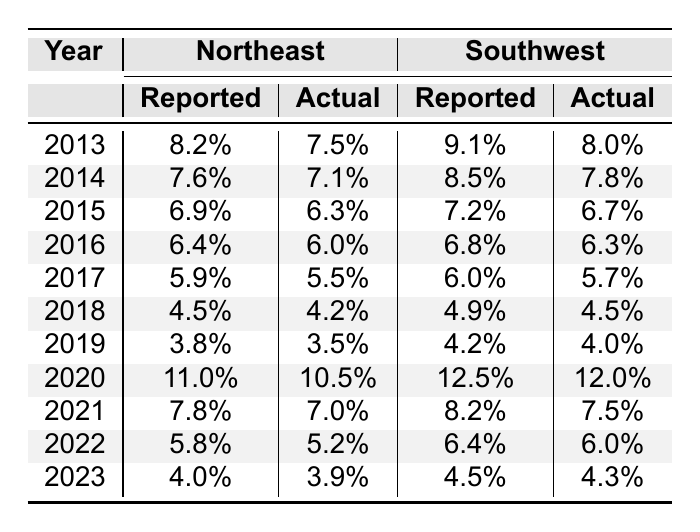What was the reported unemployment rate in the Northeast in 2020? The table shows the reported unemployment rate for the Northeast in 2020 is listed as 11.0%.
Answer: 11.0% What was the actual unemployment rate in the Southwest in 2018? The actual unemployment rate for the Southwest in 2018 is provided in the table as 4.5%.
Answer: 4.5% What is the difference between the reported and actual unemployment rates in the Northeast for 2019? The reported rate is 3.8% and the actual rate is 3.5%, hence the difference is 3.8% - 3.5% = 0.3%.
Answer: 0.3% For which year did the Northeast have the highest reported unemployment rate? By inspecting the reported unemployment rates, 11.0% in 2020 is the highest compared to other years.
Answer: 2020 Was the actual unemployment rate ever lower than 4.0% in the Southwest? In the table, the actual rates are 4.0% in 2019 and higher in other years, confirming that it was never lower than 4.0%.
Answer: No What is the average reported unemployment rate for the Northeast over the last decade? To find the average, add the reported rates (8.2 + 7.6 + 6.9 + 6.4 + 5.9 + 4.5 + 3.8 + 11.0 + 7.8 + 5.8 + 4.0 = 70.9) and divide by the number of years (11), yielding an average of 70.9 / 11 = 6.45%.
Answer: 6.45% How much did the reported unemployment rate in the Southwest change from 2013 to 2023? The reported rates show a decrease from 9.1% in 2013 to 4.5% in 2023, so the change is 9.1% - 4.5% = 4.6%.
Answer: 4.6% Which region had a higher average actual unemployment rate over the last decade, Northeast or Southwest? Calculate the averages: Northeast (7.5 + 7.1 + 6.3 + 6.0 + 5.5 + 4.2 + 3.5 + 10.5 + 7.0 + 5.2 + 3.9) = 57.7, average = 5.24%, and Southwest (8.0 + 7.8 + 6.7 + 6.3 + 5.7 + 4.5 + 4.0 + 12.0 + 7.5 + 6.0 + 4.3) = 57.8, average = 5.25%. Since 5.25% > 5.24%, the Southwest has a higher average.
Answer: Southwest What was the trend in actual unemployment rates between 2013 and 2023 for the Northeast? Analyzing the actual rates over the years shows a general decreasing trend, moving from 7.5% in 2013 down to 3.9% in 2023.
Answer: Decreasing trend 